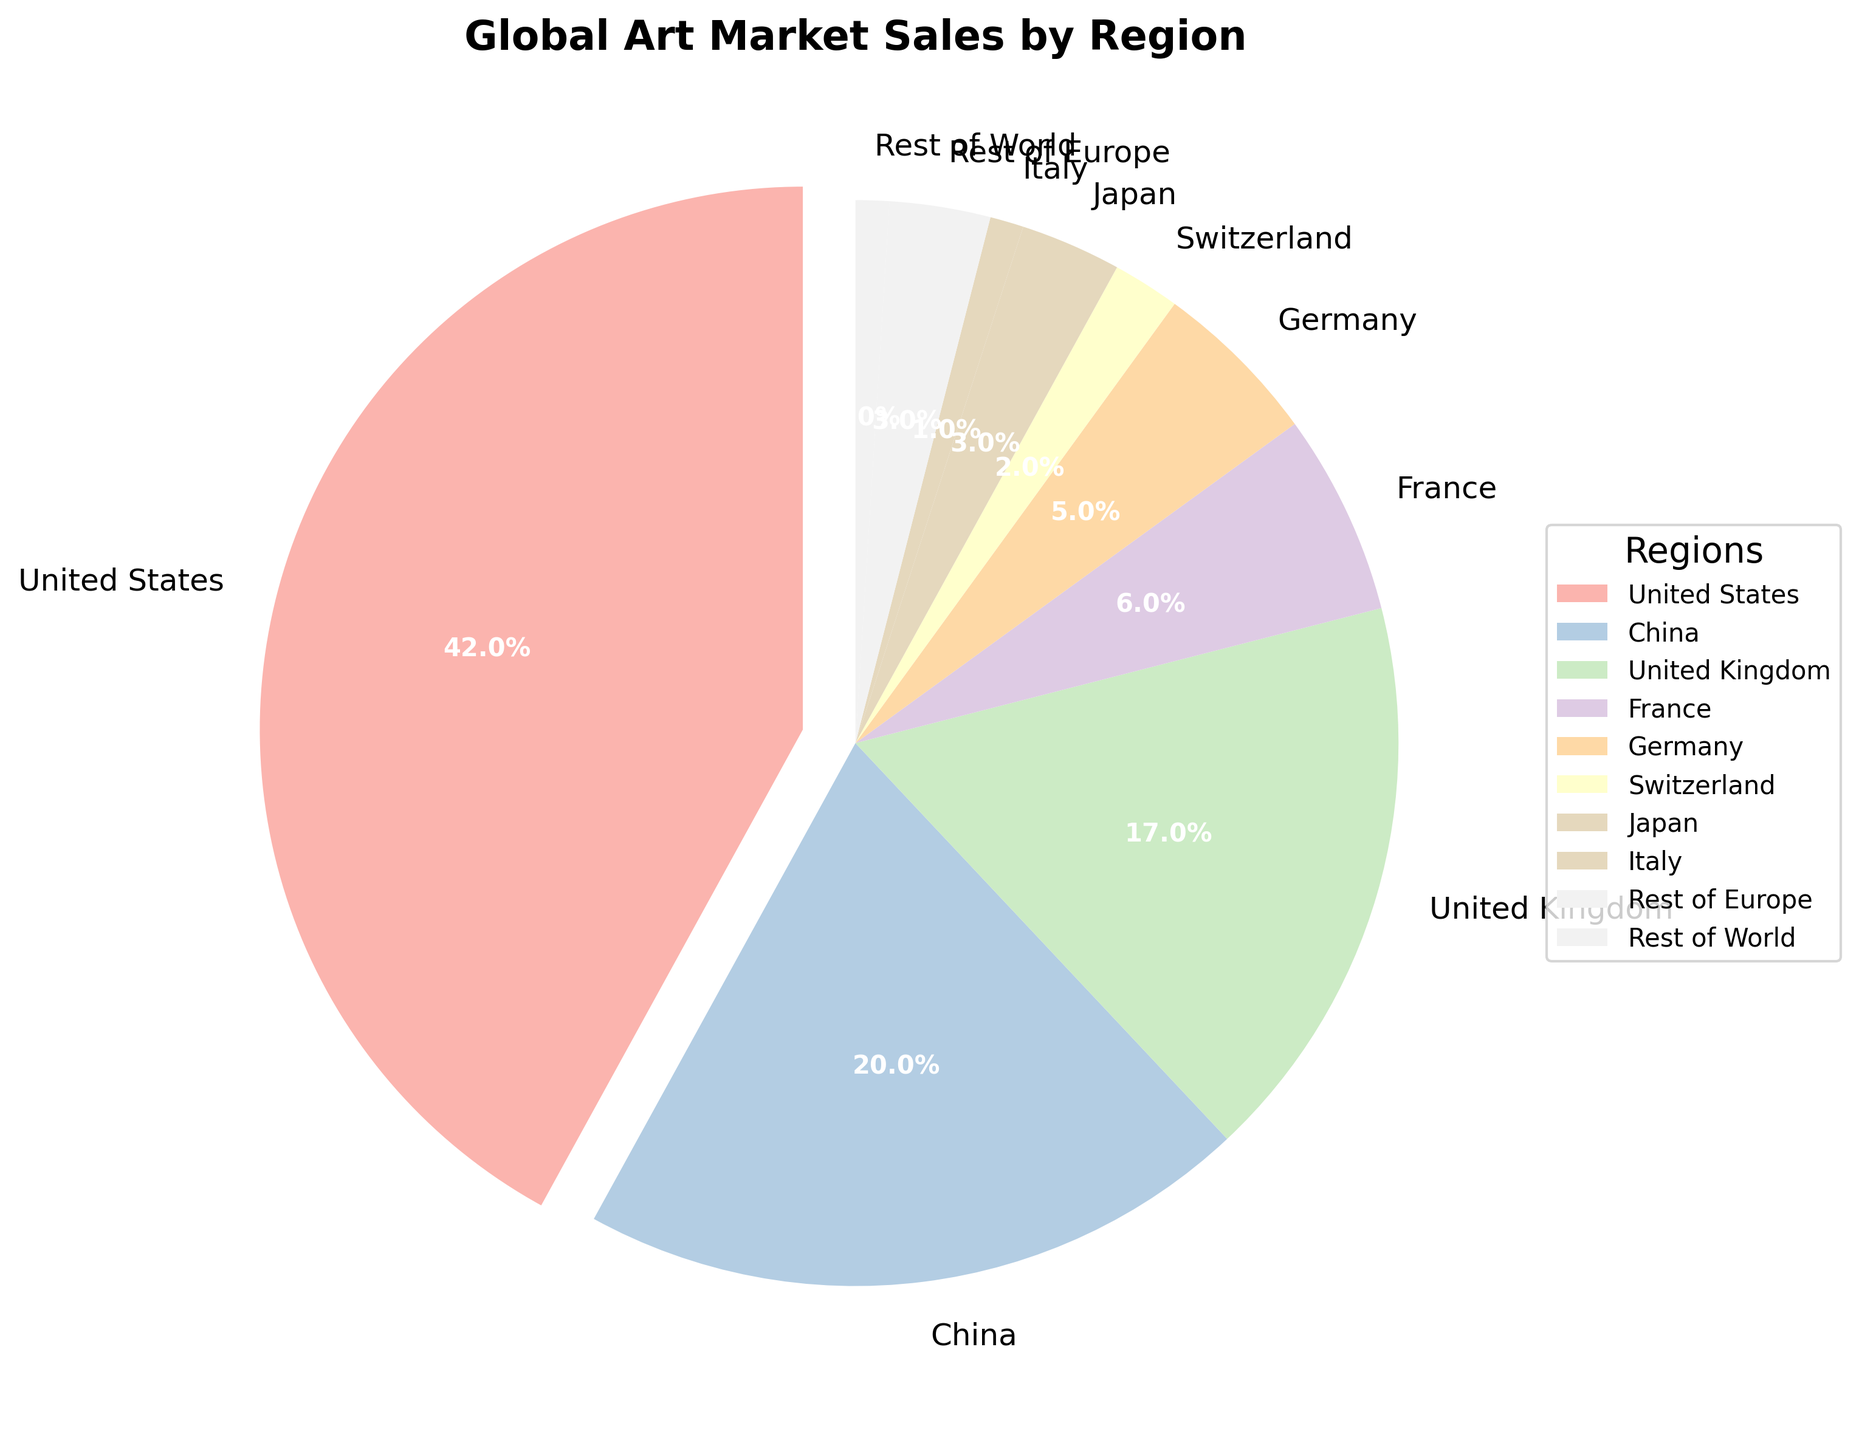What's the largest region by percentage in the global art market? The figure shows that the United States has the largest percentage, and its segment is the most emphasized with a slightly exploded visual representation.
Answer: United States Which regions have less than 5% of the market share? By looking at the figure, Japan (3%), Switzerland (2%), Italy (1%), and Rest of World (1%) all have market shares less than 5%.
Answer: Japan, Switzerland, Italy, Rest of World What is the total percentage of the top 3 regions combined? The top 3 regions by percentage are the United States (42%), China (20%), and United Kingdom (17%). Adding these gives 42% + 20% + 17% = 79%.
Answer: 79% How does Germany's market share compare to France's? From the figure, Germany has a market share of 5%, while France has 6%. Germany's market share is 1% less than France's.
Answer: Germany has 1% less than France Which region represents the smallest portion of the global art market sales? Italy and the Rest of World both have the smallest portion at 1% each.
Answer: Italy, Rest of World What is the combined market share of all European regions (including the UK)? The European regions listed are the United Kingdom (17%), France (6%), Germany (5%), Switzerland (2%), Italy (1%), and Rest of Europe (3%). Adding these gives 17% + 6% + 5% + 2% + 1% + 3% = 34%.
Answer: 34% Is China's market share more or less than twice that of the United Kingdom's? China's market share is 20% and the United Kingdom's is 17%. Twice the UK's share would be 34%. Since 20% is less than 34%, China's market share is less than twice the UK's.
Answer: Less Which region appears in blue? By visually inspecting the pie chart with the given color palette, we can identify the color assignments. One region appears in pastel blue according to the pie chart color distribution, and it is the segment labeled with Rest of Europe.
Answer: Rest of Europe 